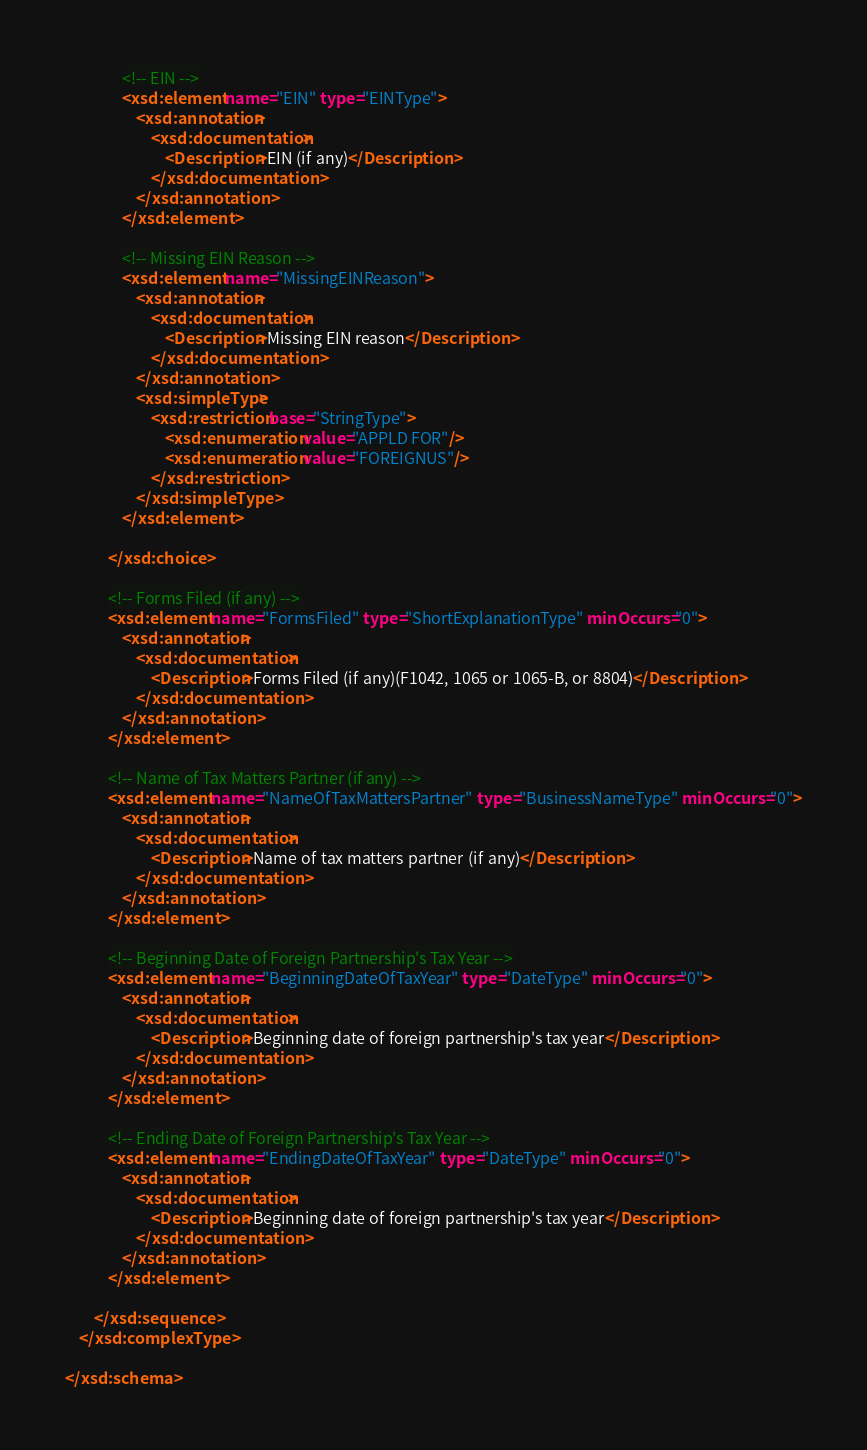<code> <loc_0><loc_0><loc_500><loc_500><_XML_>				<!-- EIN -->
				<xsd:element name="EIN" type="EINType">
					<xsd:annotation>
						<xsd:documentation>
							<Description>EIN (if any)</Description>
						</xsd:documentation>
					</xsd:annotation>
				</xsd:element>

				<!-- Missing EIN Reason -->
				<xsd:element name="MissingEINReason">
					<xsd:annotation>
						<xsd:documentation>
							<Description>Missing EIN reason</Description>
						</xsd:documentation>
					</xsd:annotation>
					<xsd:simpleType>
						<xsd:restriction base="StringType">
							<xsd:enumeration value="APPLD FOR"/>
							<xsd:enumeration value="FOREIGNUS"/>
						</xsd:restriction>
					</xsd:simpleType>
				</xsd:element>

			</xsd:choice>

			<!-- Forms Filed (if any) -->
			<xsd:element name="FormsFiled" type="ShortExplanationType" minOccurs="0">
				<xsd:annotation>
					<xsd:documentation>
						<Description>Forms Filed (if any)(F1042, 1065 or 1065-B, or 8804)</Description>
					</xsd:documentation>
				</xsd:annotation>
			</xsd:element>

			<!-- Name of Tax Matters Partner (if any) -->
			<xsd:element name="NameOfTaxMattersPartner" type="BusinessNameType" minOccurs="0">
				<xsd:annotation>
					<xsd:documentation>
						<Description>Name of tax matters partner (if any)</Description>
					</xsd:documentation>
				</xsd:annotation>
			</xsd:element>

			<!-- Beginning Date of Foreign Partnership's Tax Year -->
			<xsd:element name="BeginningDateOfTaxYear" type="DateType" minOccurs="0">
				<xsd:annotation>
					<xsd:documentation>
						<Description>Beginning date of foreign partnership's tax year</Description>
					</xsd:documentation>
				</xsd:annotation>
			</xsd:element>

			<!-- Ending Date of Foreign Partnership's Tax Year -->
			<xsd:element name="EndingDateOfTaxYear" type="DateType" minOccurs="0">
				<xsd:annotation>
					<xsd:documentation>
						<Description>Beginning date of foreign partnership's tax year</Description>
					</xsd:documentation>
				</xsd:annotation>
			</xsd:element>

		</xsd:sequence>
	</xsd:complexType>

</xsd:schema>
</code> 